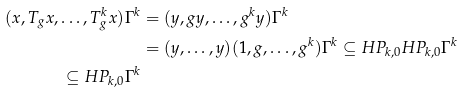Convert formula to latex. <formula><loc_0><loc_0><loc_500><loc_500>( x , T _ { g } x , \dots , T _ { g } ^ { k } x ) \Gamma ^ { k } & = ( y , g y , \dots , g ^ { k } y ) \Gamma ^ { k } \\ & = ( y , \dots , y ) ( 1 , g , \dots , g ^ { k } ) \Gamma ^ { k } \subseteq H P _ { k , 0 } H P _ { k , 0 } \Gamma ^ { k } \\ \subseteq H P _ { k , 0 } \Gamma ^ { k }</formula> 